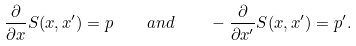<formula> <loc_0><loc_0><loc_500><loc_500>\frac { \partial } { \partial x } S ( x , x ^ { \prime } ) = p \quad a n d \quad - \frac { \partial } { \partial x ^ { \prime } } S ( x , x ^ { \prime } ) = p ^ { \prime } .</formula> 